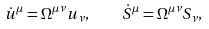Convert formula to latex. <formula><loc_0><loc_0><loc_500><loc_500>\dot { u } ^ { \mu } = \Omega ^ { \mu \nu } u _ { \nu } , \quad \dot { S } ^ { \mu } = \Omega ^ { \mu \nu } S _ { \nu } ,</formula> 